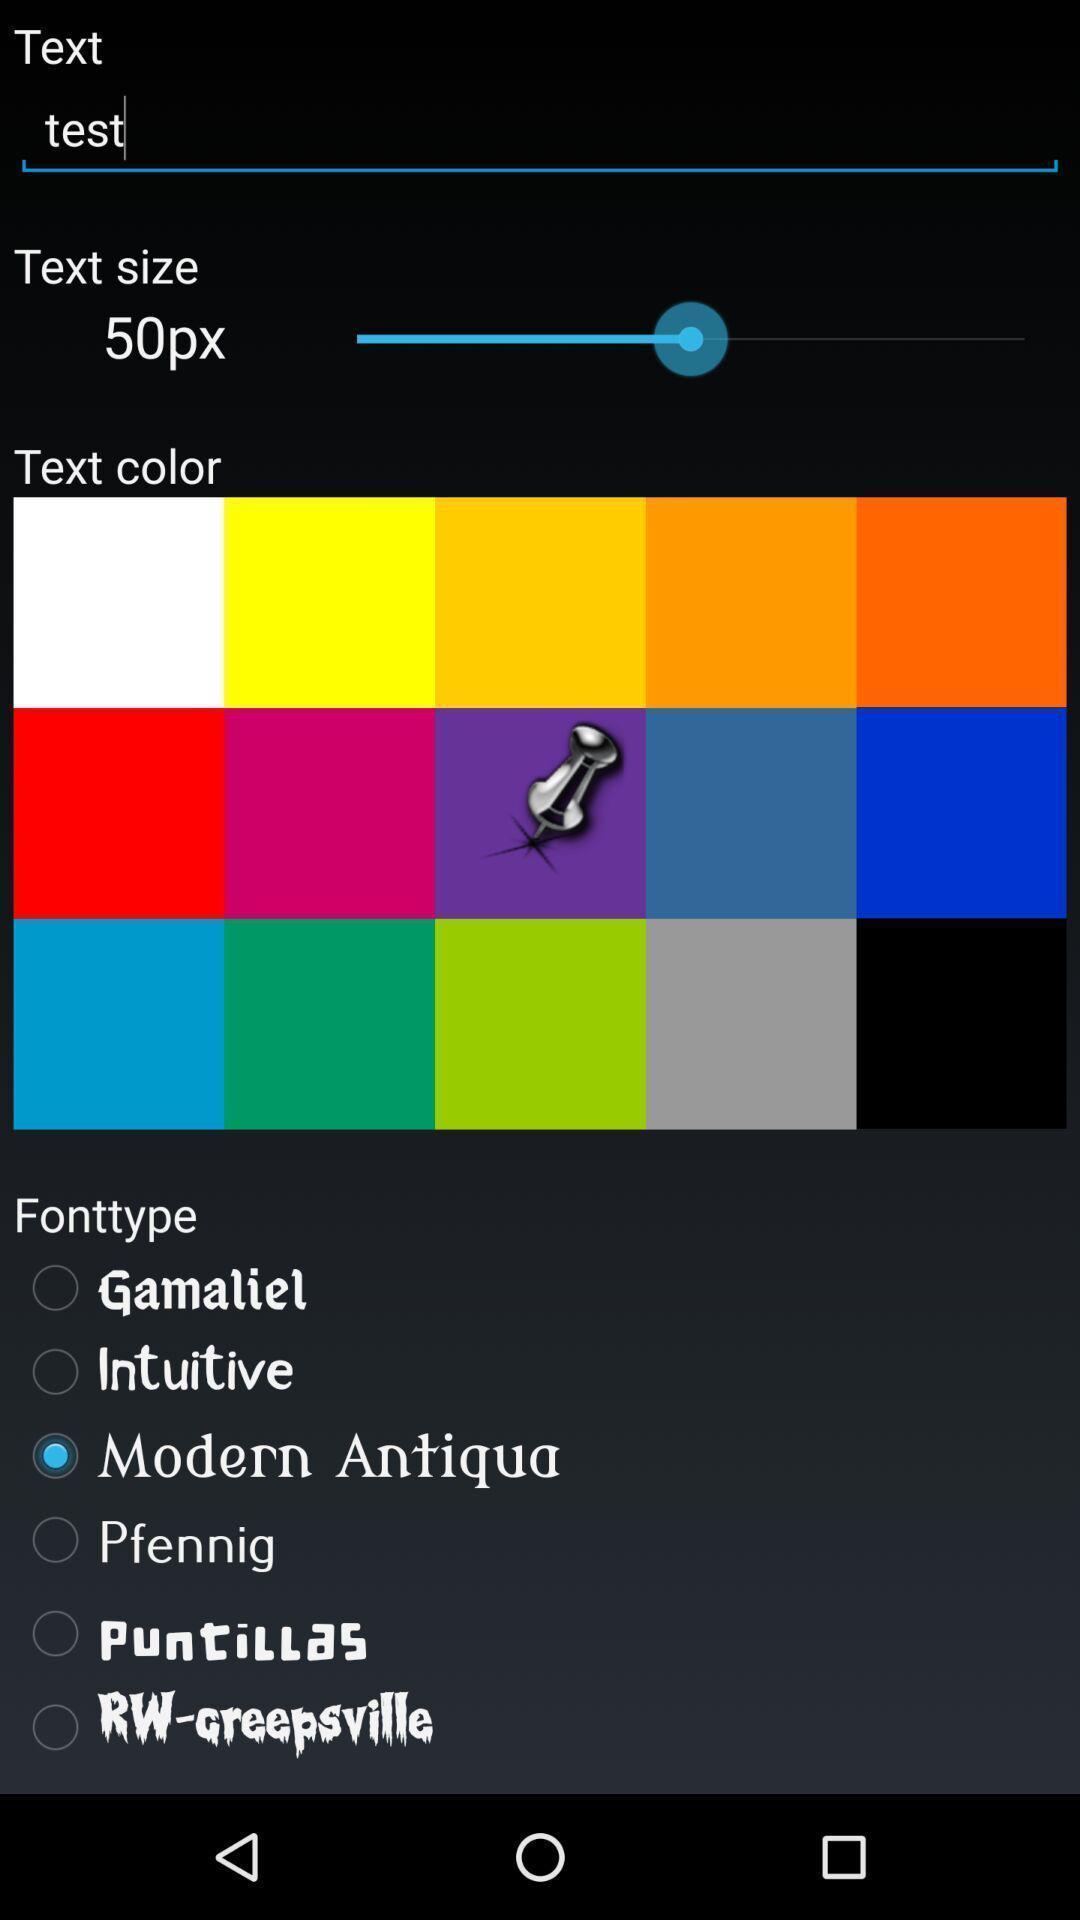Describe the key features of this screenshot. Page displays different categories for text format. 